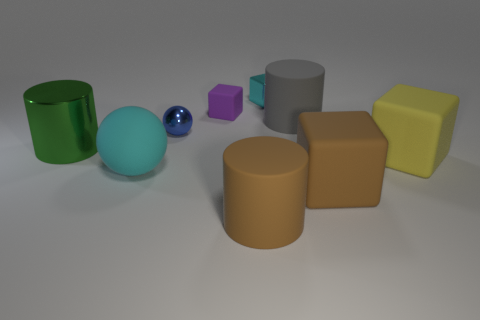The cyan thing that is made of the same material as the green object is what size?
Keep it short and to the point. Small. Are there an equal number of green metallic things that are in front of the brown matte block and brown blocks?
Make the answer very short. No. Is the color of the small shiny ball the same as the big metal thing?
Make the answer very short. No. There is a shiny thing to the left of the cyan ball; is its shape the same as the big brown rubber object that is right of the gray cylinder?
Provide a short and direct response. No. There is a tiny purple thing that is the same shape as the large yellow thing; what is its material?
Offer a terse response. Rubber. There is a cylinder that is both to the right of the green metal cylinder and behind the brown cylinder; what color is it?
Your answer should be very brief. Gray. There is a tiny metal object right of the brown thing that is left of the metallic cube; are there any cylinders that are behind it?
Offer a terse response. No. How many objects are metallic spheres or small rubber cubes?
Your answer should be very brief. 2. Are the big brown cylinder and the cyan thing that is to the right of the cyan matte sphere made of the same material?
Offer a terse response. No. Are there any other things that have the same color as the big matte sphere?
Ensure brevity in your answer.  Yes. 